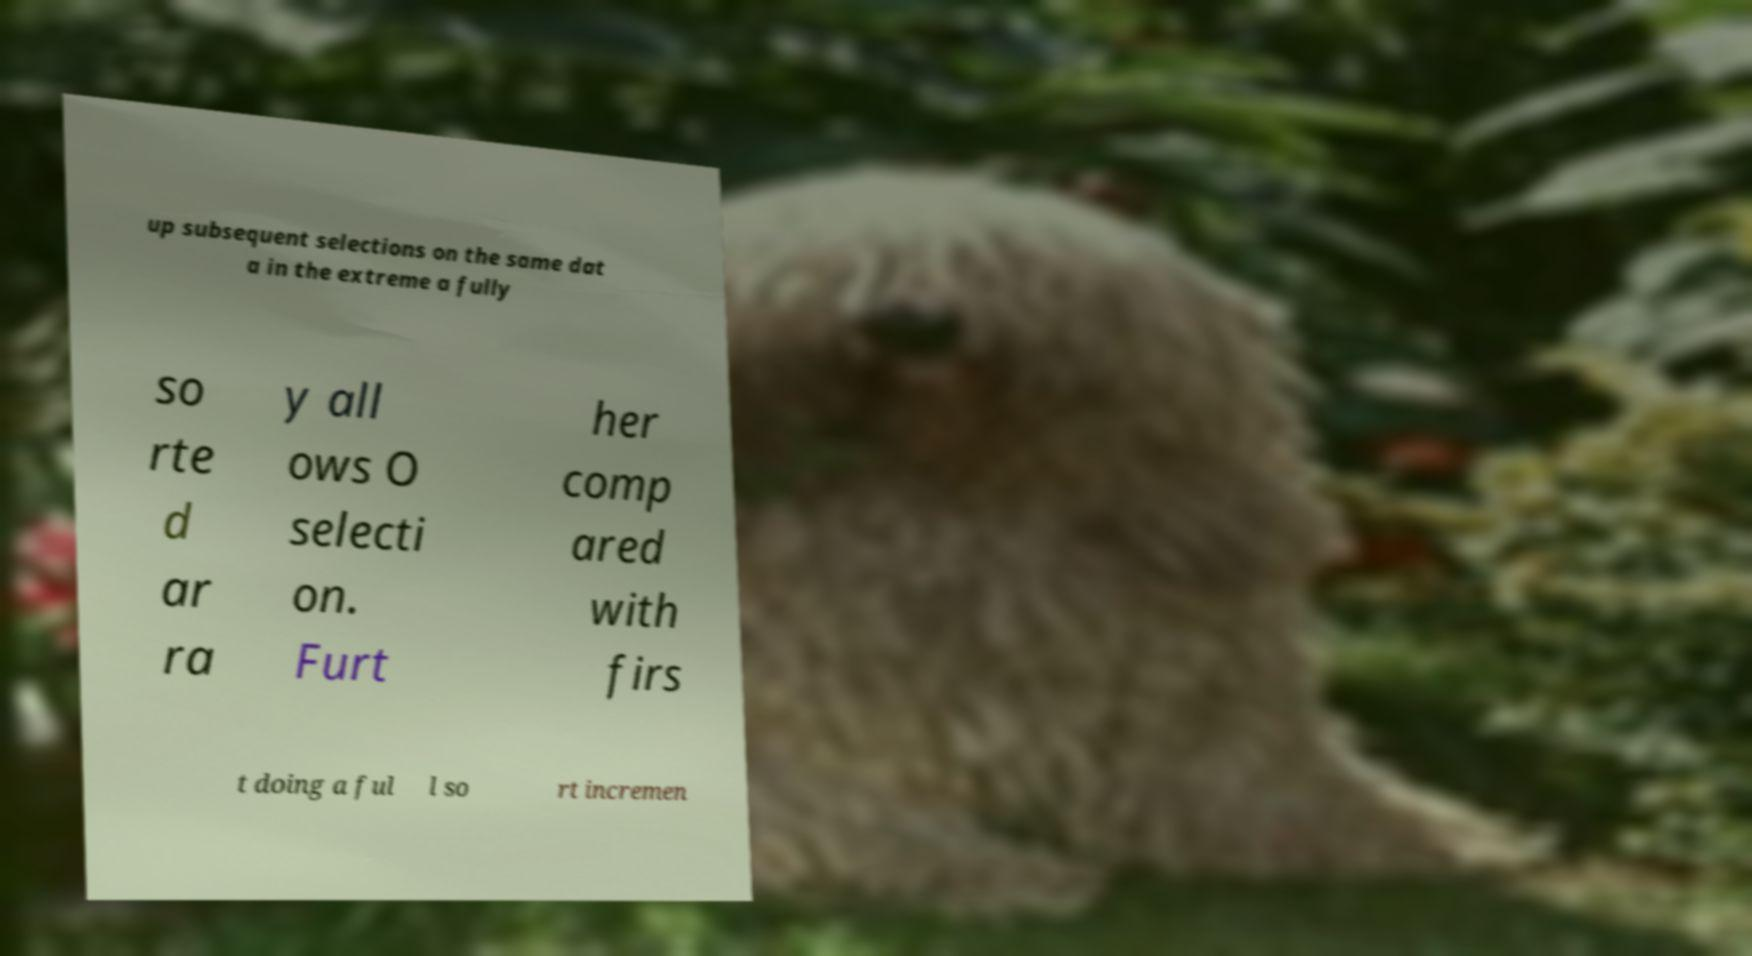Could you extract and type out the text from this image? up subsequent selections on the same dat a in the extreme a fully so rte d ar ra y all ows O selecti on. Furt her comp ared with firs t doing a ful l so rt incremen 